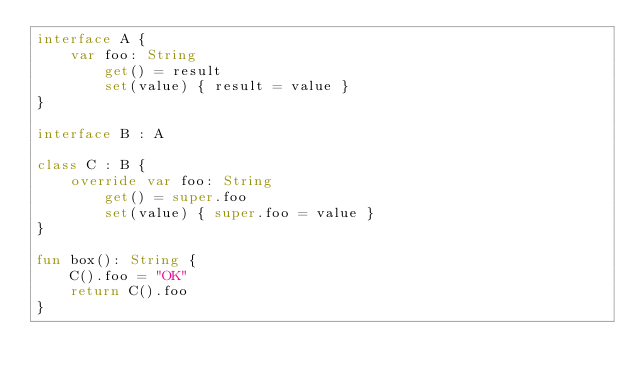Convert code to text. <code><loc_0><loc_0><loc_500><loc_500><_Kotlin_>interface A {
    var foo: String
        get() = result
        set(value) { result = value }
}

interface B : A

class C : B {
    override var foo: String
        get() = super.foo
        set(value) { super.foo = value }
}

fun box(): String {
    C().foo = "OK"
    return C().foo
}
</code> 